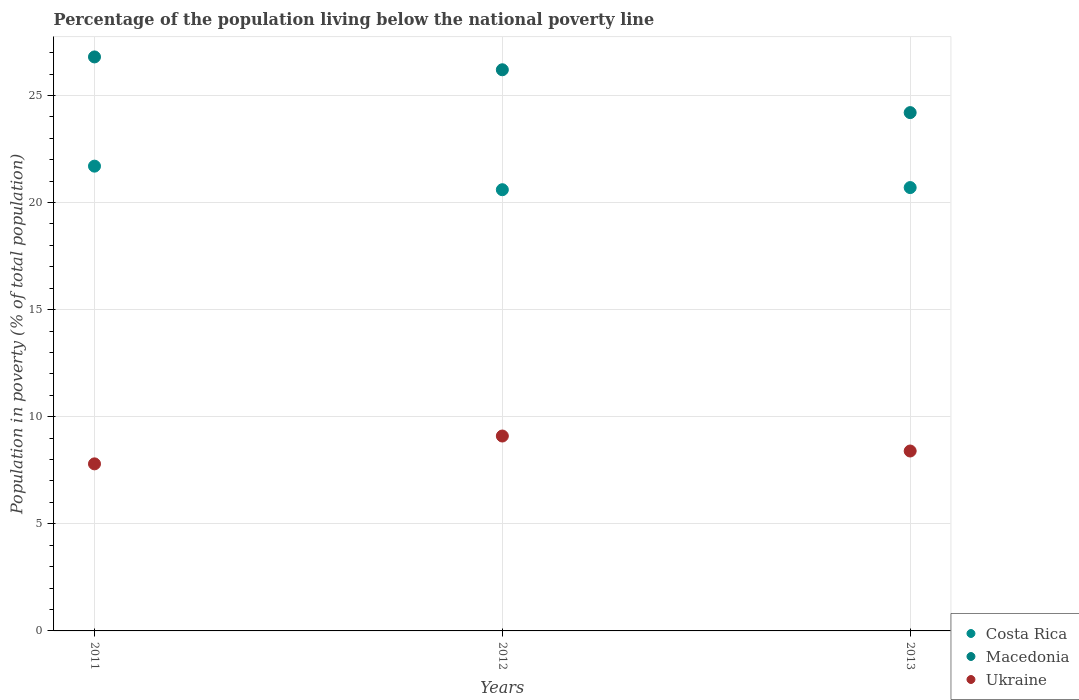How many different coloured dotlines are there?
Offer a terse response. 3. What is the percentage of the population living below the national poverty line in Costa Rica in 2011?
Make the answer very short. 21.7. Across all years, what is the minimum percentage of the population living below the national poverty line in Macedonia?
Give a very brief answer. 24.2. In which year was the percentage of the population living below the national poverty line in Macedonia maximum?
Make the answer very short. 2011. In which year was the percentage of the population living below the national poverty line in Macedonia minimum?
Keep it short and to the point. 2013. What is the total percentage of the population living below the national poverty line in Macedonia in the graph?
Give a very brief answer. 77.2. What is the difference between the percentage of the population living below the national poverty line in Ukraine in 2011 and that in 2012?
Make the answer very short. -1.3. What is the difference between the percentage of the population living below the national poverty line in Macedonia in 2013 and the percentage of the population living below the national poverty line in Ukraine in 2012?
Provide a succinct answer. 15.1. What is the average percentage of the population living below the national poverty line in Macedonia per year?
Your answer should be very brief. 25.73. In the year 2012, what is the difference between the percentage of the population living below the national poverty line in Macedonia and percentage of the population living below the national poverty line in Ukraine?
Offer a terse response. 17.1. What is the ratio of the percentage of the population living below the national poverty line in Ukraine in 2011 to that in 2013?
Your answer should be compact. 0.93. Is the difference between the percentage of the population living below the national poverty line in Macedonia in 2012 and 2013 greater than the difference between the percentage of the population living below the national poverty line in Ukraine in 2012 and 2013?
Make the answer very short. Yes. What is the difference between the highest and the second highest percentage of the population living below the national poverty line in Macedonia?
Give a very brief answer. 0.6. What is the difference between the highest and the lowest percentage of the population living below the national poverty line in Ukraine?
Keep it short and to the point. 1.3. In how many years, is the percentage of the population living below the national poverty line in Macedonia greater than the average percentage of the population living below the national poverty line in Macedonia taken over all years?
Your response must be concise. 2. Is the sum of the percentage of the population living below the national poverty line in Macedonia in 2011 and 2013 greater than the maximum percentage of the population living below the national poverty line in Costa Rica across all years?
Provide a succinct answer. Yes. Does the percentage of the population living below the national poverty line in Ukraine monotonically increase over the years?
Provide a succinct answer. No. Is the percentage of the population living below the national poverty line in Ukraine strictly greater than the percentage of the population living below the national poverty line in Macedonia over the years?
Your answer should be compact. No. How many dotlines are there?
Provide a succinct answer. 3. Does the graph contain grids?
Offer a very short reply. Yes. Where does the legend appear in the graph?
Ensure brevity in your answer.  Bottom right. How are the legend labels stacked?
Ensure brevity in your answer.  Vertical. What is the title of the graph?
Your answer should be very brief. Percentage of the population living below the national poverty line. Does "Oman" appear as one of the legend labels in the graph?
Make the answer very short. No. What is the label or title of the Y-axis?
Give a very brief answer. Population in poverty (% of total population). What is the Population in poverty (% of total population) of Costa Rica in 2011?
Offer a very short reply. 21.7. What is the Population in poverty (% of total population) of Macedonia in 2011?
Make the answer very short. 26.8. What is the Population in poverty (% of total population) in Costa Rica in 2012?
Your answer should be very brief. 20.6. What is the Population in poverty (% of total population) of Macedonia in 2012?
Your answer should be compact. 26.2. What is the Population in poverty (% of total population) of Costa Rica in 2013?
Keep it short and to the point. 20.7. What is the Population in poverty (% of total population) in Macedonia in 2013?
Provide a succinct answer. 24.2. What is the Population in poverty (% of total population) in Ukraine in 2013?
Provide a succinct answer. 8.4. Across all years, what is the maximum Population in poverty (% of total population) of Costa Rica?
Offer a very short reply. 21.7. Across all years, what is the maximum Population in poverty (% of total population) in Macedonia?
Your answer should be very brief. 26.8. Across all years, what is the minimum Population in poverty (% of total population) of Costa Rica?
Your answer should be compact. 20.6. Across all years, what is the minimum Population in poverty (% of total population) of Macedonia?
Provide a succinct answer. 24.2. Across all years, what is the minimum Population in poverty (% of total population) of Ukraine?
Ensure brevity in your answer.  7.8. What is the total Population in poverty (% of total population) of Costa Rica in the graph?
Provide a short and direct response. 63. What is the total Population in poverty (% of total population) in Macedonia in the graph?
Make the answer very short. 77.2. What is the total Population in poverty (% of total population) in Ukraine in the graph?
Make the answer very short. 25.3. What is the difference between the Population in poverty (% of total population) of Costa Rica in 2011 and that in 2012?
Give a very brief answer. 1.1. What is the difference between the Population in poverty (% of total population) in Macedonia in 2011 and that in 2012?
Provide a succinct answer. 0.6. What is the difference between the Population in poverty (% of total population) of Ukraine in 2011 and that in 2012?
Keep it short and to the point. -1.3. What is the difference between the Population in poverty (% of total population) in Ukraine in 2011 and that in 2013?
Offer a very short reply. -0.6. What is the difference between the Population in poverty (% of total population) of Costa Rica in 2011 and the Population in poverty (% of total population) of Ukraine in 2013?
Ensure brevity in your answer.  13.3. What is the difference between the Population in poverty (% of total population) of Macedonia in 2011 and the Population in poverty (% of total population) of Ukraine in 2013?
Keep it short and to the point. 18.4. What is the difference between the Population in poverty (% of total population) of Costa Rica in 2012 and the Population in poverty (% of total population) of Macedonia in 2013?
Your response must be concise. -3.6. What is the difference between the Population in poverty (% of total population) in Costa Rica in 2012 and the Population in poverty (% of total population) in Ukraine in 2013?
Make the answer very short. 12.2. What is the difference between the Population in poverty (% of total population) in Macedonia in 2012 and the Population in poverty (% of total population) in Ukraine in 2013?
Offer a very short reply. 17.8. What is the average Population in poverty (% of total population) of Macedonia per year?
Ensure brevity in your answer.  25.73. What is the average Population in poverty (% of total population) of Ukraine per year?
Ensure brevity in your answer.  8.43. In the year 2012, what is the difference between the Population in poverty (% of total population) of Costa Rica and Population in poverty (% of total population) of Macedonia?
Offer a very short reply. -5.6. In the year 2012, what is the difference between the Population in poverty (% of total population) in Costa Rica and Population in poverty (% of total population) in Ukraine?
Provide a succinct answer. 11.5. In the year 2012, what is the difference between the Population in poverty (% of total population) in Macedonia and Population in poverty (% of total population) in Ukraine?
Your answer should be very brief. 17.1. In the year 2013, what is the difference between the Population in poverty (% of total population) of Costa Rica and Population in poverty (% of total population) of Macedonia?
Your answer should be compact. -3.5. In the year 2013, what is the difference between the Population in poverty (% of total population) of Costa Rica and Population in poverty (% of total population) of Ukraine?
Your response must be concise. 12.3. In the year 2013, what is the difference between the Population in poverty (% of total population) of Macedonia and Population in poverty (% of total population) of Ukraine?
Make the answer very short. 15.8. What is the ratio of the Population in poverty (% of total population) of Costa Rica in 2011 to that in 2012?
Your response must be concise. 1.05. What is the ratio of the Population in poverty (% of total population) of Macedonia in 2011 to that in 2012?
Offer a very short reply. 1.02. What is the ratio of the Population in poverty (% of total population) in Costa Rica in 2011 to that in 2013?
Offer a very short reply. 1.05. What is the ratio of the Population in poverty (% of total population) in Macedonia in 2011 to that in 2013?
Your answer should be compact. 1.11. What is the ratio of the Population in poverty (% of total population) in Ukraine in 2011 to that in 2013?
Make the answer very short. 0.93. What is the ratio of the Population in poverty (% of total population) of Costa Rica in 2012 to that in 2013?
Ensure brevity in your answer.  1. What is the ratio of the Population in poverty (% of total population) of Macedonia in 2012 to that in 2013?
Your response must be concise. 1.08. What is the difference between the highest and the second highest Population in poverty (% of total population) in Macedonia?
Ensure brevity in your answer.  0.6. What is the difference between the highest and the lowest Population in poverty (% of total population) of Costa Rica?
Offer a very short reply. 1.1. What is the difference between the highest and the lowest Population in poverty (% of total population) in Ukraine?
Make the answer very short. 1.3. 